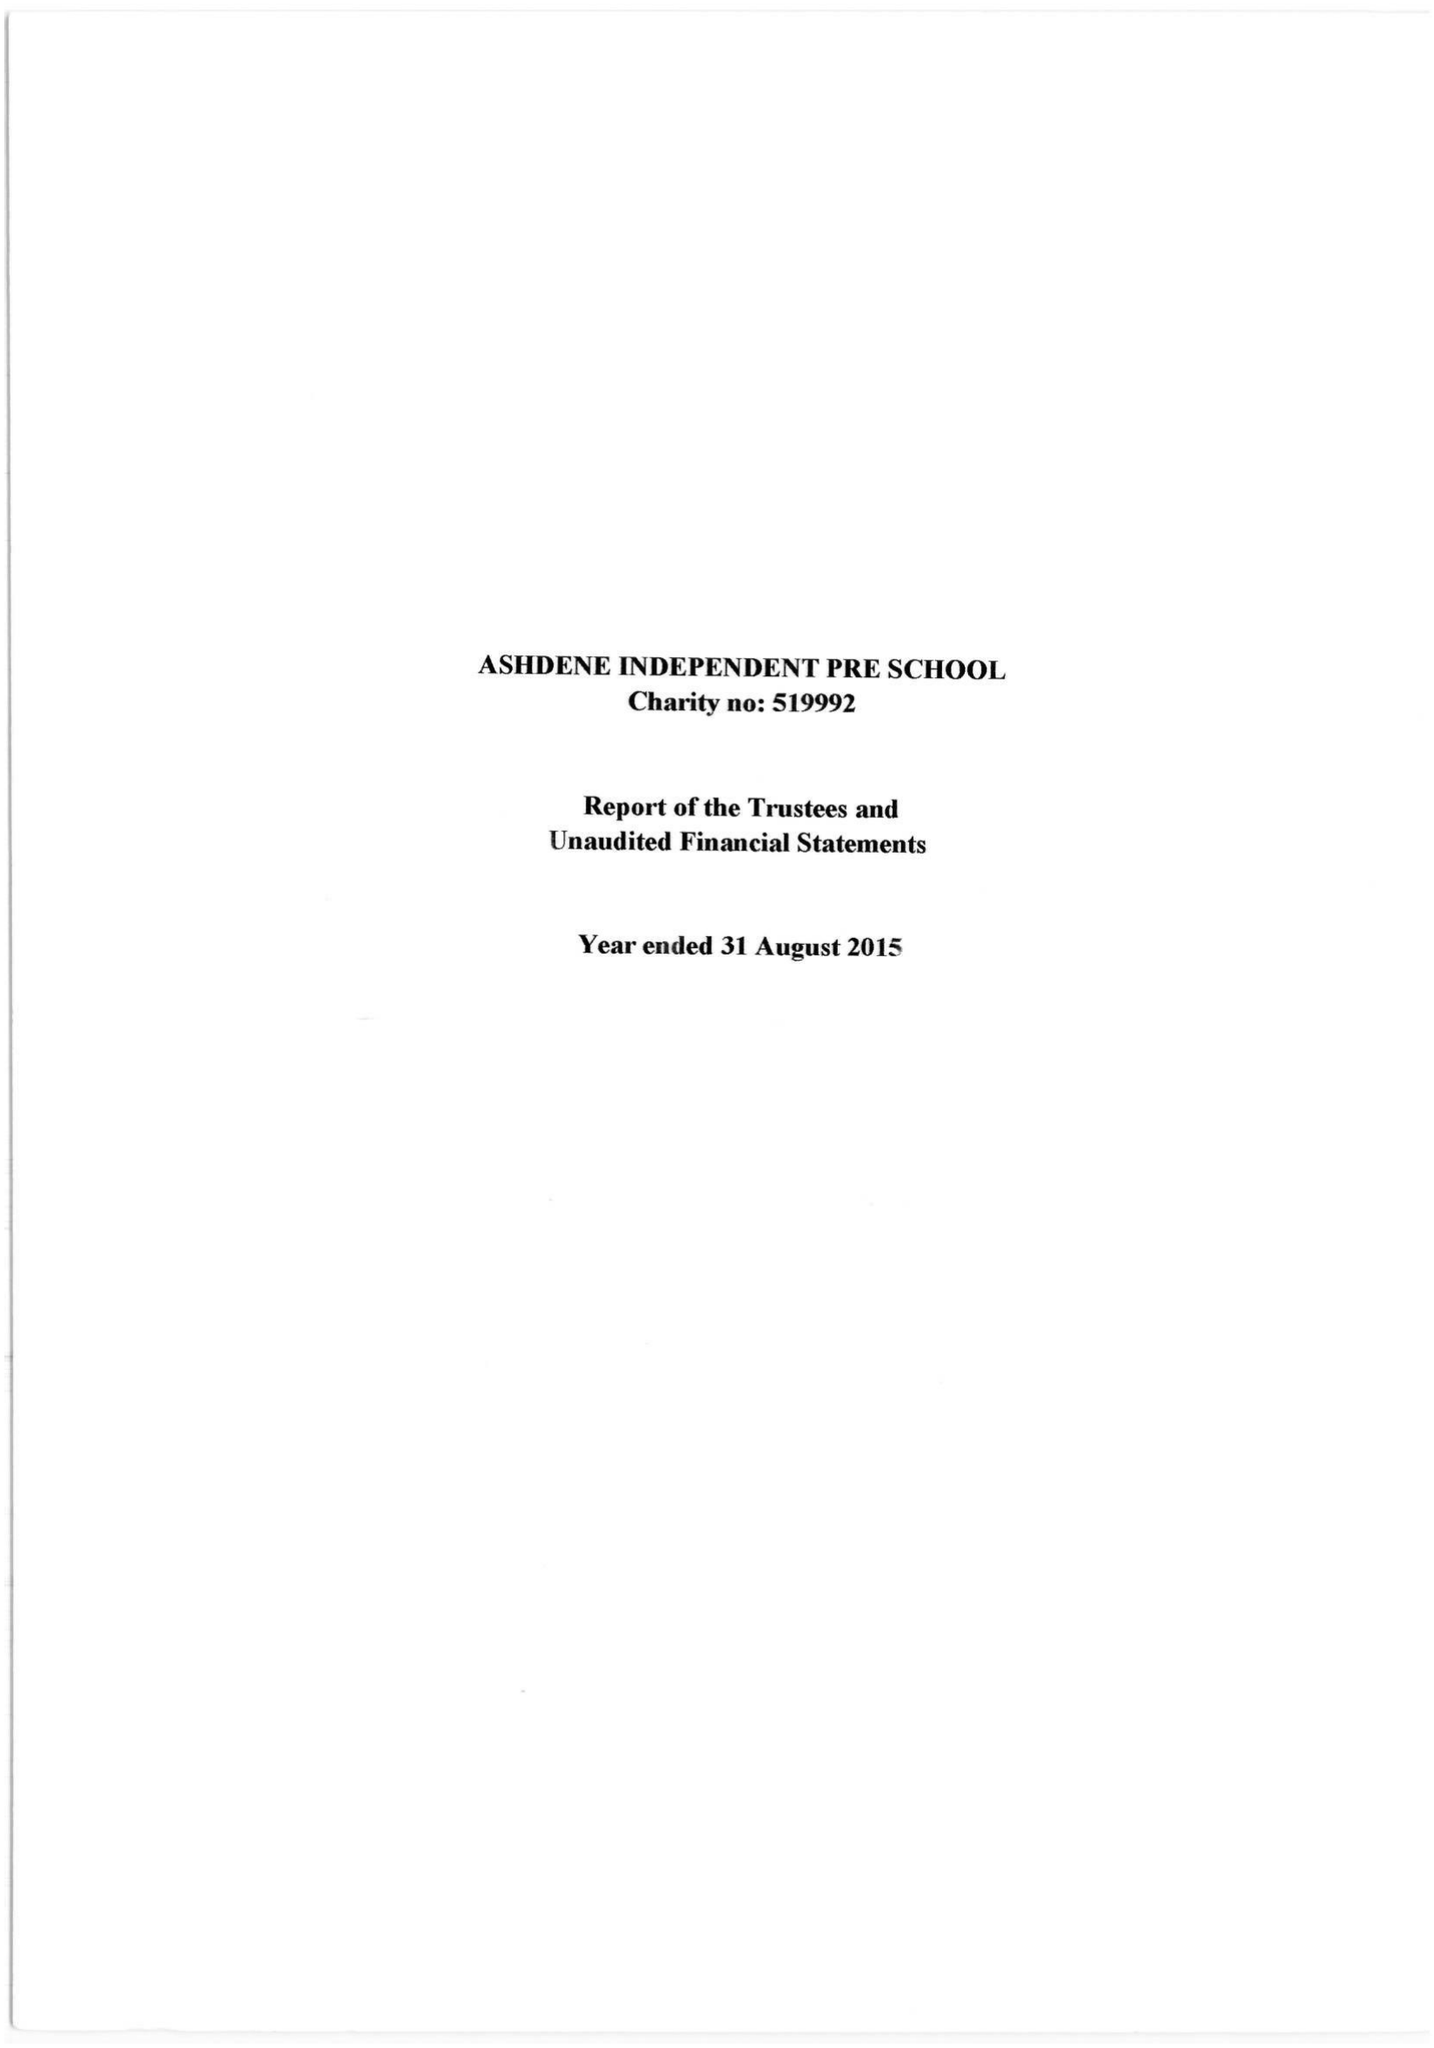What is the value for the report_date?
Answer the question using a single word or phrase. 2015-08-31 